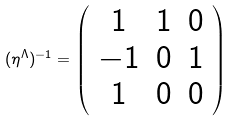Convert formula to latex. <formula><loc_0><loc_0><loc_500><loc_500>( { \eta } ^ { \Lambda } ) ^ { - 1 } = \left ( \begin{array} { c c c } 1 & 1 & 0 \\ - 1 & 0 & 1 \\ 1 & 0 & 0 \\ \end{array} \right )</formula> 